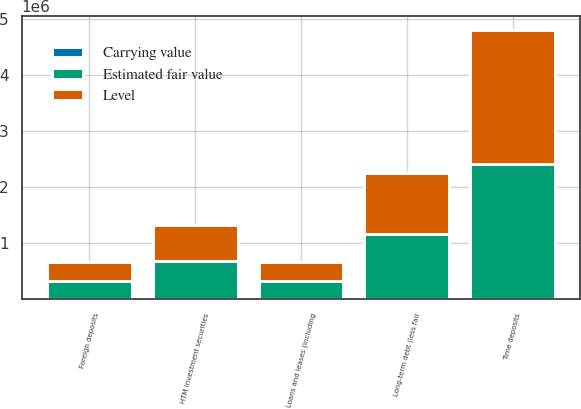Convert chart. <chart><loc_0><loc_0><loc_500><loc_500><stacked_bar_chart><ecel><fcel>HTM investment securities<fcel>Loans and leases (including<fcel>Time deposits<fcel>Foreign deposits<fcel>Long-term debt (less fair<nl><fcel>Level<fcel>647252<fcel>328447<fcel>2.40692e+06<fcel>328391<fcel>1.09078e+06<nl><fcel>Estimated fair value<fcel>677196<fcel>328447<fcel>2.40855e+06<fcel>328447<fcel>1.15929e+06<nl><fcel>Carrying value<fcel>3<fcel>3<fcel>2<fcel>2<fcel>2<nl></chart> 